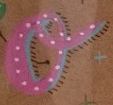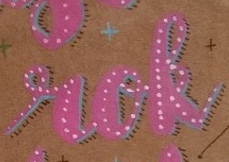What words can you see in these images in sequence, separated by a semicolon? o; rok 